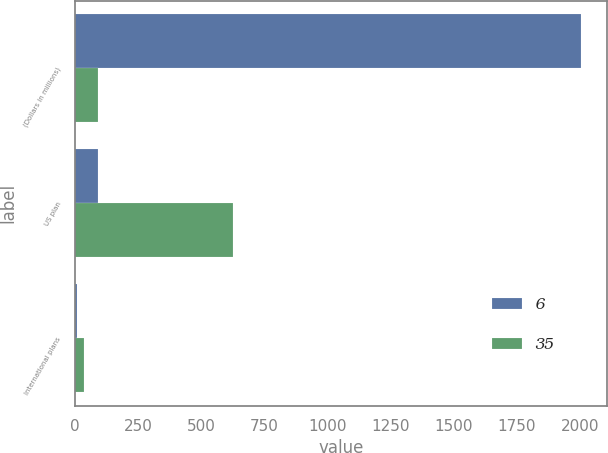Convert chart. <chart><loc_0><loc_0><loc_500><loc_500><stacked_bar_chart><ecel><fcel>(Dollars in millions)<fcel>US plan<fcel>International plans<nl><fcel>6<fcel>2007<fcel>90<fcel>6<nl><fcel>35<fcel>90<fcel>627<fcel>35<nl></chart> 